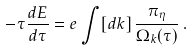Convert formula to latex. <formula><loc_0><loc_0><loc_500><loc_500>- \tau \frac { d E } { d \tau } = e \int [ d { k } ] \, \frac { \pi _ { \eta } } { \Omega _ { k } ( \tau ) } \, .</formula> 